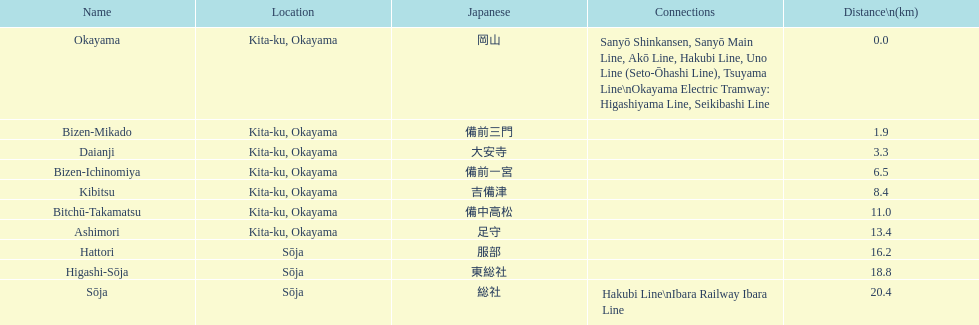How many stations are located within 15km? 7. 